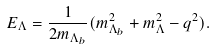Convert formula to latex. <formula><loc_0><loc_0><loc_500><loc_500>E _ { \Lambda } = \frac { 1 } { 2 m _ { \Lambda _ { b } } } ( m _ { \Lambda _ { b } } ^ { 2 } + m _ { \Lambda } ^ { 2 } - q ^ { 2 } ) .</formula> 